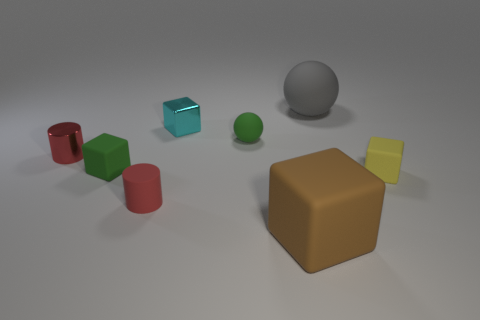Are there more large brown things behind the red matte cylinder than blue matte cylinders?
Give a very brief answer. No. How many other objects are there of the same size as the red rubber thing?
Your answer should be compact. 5. How many tiny yellow cubes are behind the big gray object?
Make the answer very short. 0. Are there an equal number of red metallic objects that are on the right side of the red matte cylinder and small cyan metal cubes that are on the left side of the tiny cyan object?
Give a very brief answer. Yes. There is another thing that is the same shape as the red matte object; what is its size?
Provide a short and direct response. Small. The tiny red object that is behind the small yellow block has what shape?
Ensure brevity in your answer.  Cylinder. Do the tiny red object that is behind the tiny red rubber cylinder and the cylinder right of the small green block have the same material?
Provide a short and direct response. No. The small cyan shiny thing has what shape?
Ensure brevity in your answer.  Cube. Are there an equal number of cyan shiny things that are on the right side of the big gray matte ball and cyan metal objects?
Ensure brevity in your answer.  No. What size is the thing that is the same color as the metallic cylinder?
Provide a short and direct response. Small. 